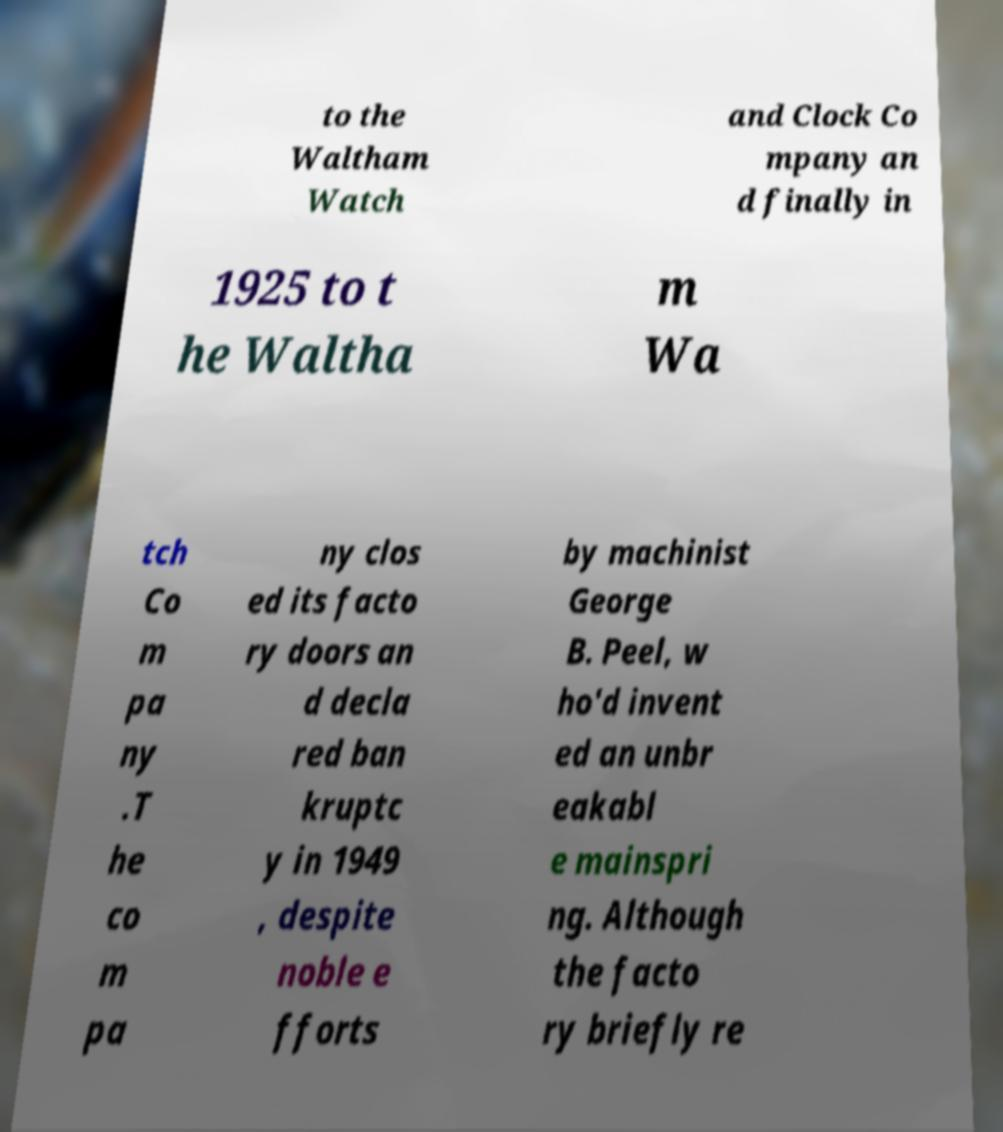Can you read and provide the text displayed in the image?This photo seems to have some interesting text. Can you extract and type it out for me? to the Waltham Watch and Clock Co mpany an d finally in 1925 to t he Waltha m Wa tch Co m pa ny .T he co m pa ny clos ed its facto ry doors an d decla red ban kruptc y in 1949 , despite noble e fforts by machinist George B. Peel, w ho'd invent ed an unbr eakabl e mainspri ng. Although the facto ry briefly re 